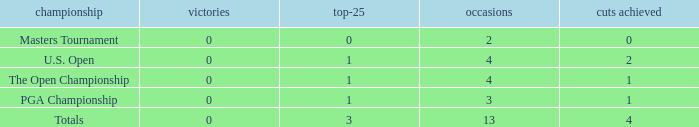How many cuts made in the tournament he played 13 times? None. Can you give me this table as a dict? {'header': ['championship', 'victories', 'top-25', 'occasions', 'cuts achieved'], 'rows': [['Masters Tournament', '0', '0', '2', '0'], ['U.S. Open', '0', '1', '4', '2'], ['The Open Championship', '0', '1', '4', '1'], ['PGA Championship', '0', '1', '3', '1'], ['Totals', '0', '3', '13', '4']]} 